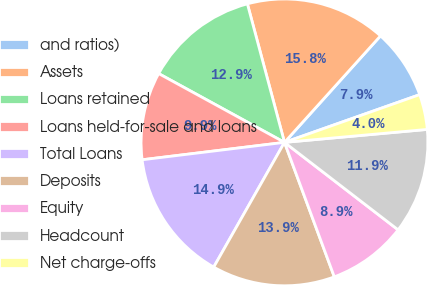Convert chart to OTSL. <chart><loc_0><loc_0><loc_500><loc_500><pie_chart><fcel>and ratios)<fcel>Assets<fcel>Loans retained<fcel>Loans held-for-sale and loans<fcel>Total Loans<fcel>Deposits<fcel>Equity<fcel>Headcount<fcel>Net charge-offs<nl><fcel>7.92%<fcel>15.84%<fcel>12.87%<fcel>9.9%<fcel>14.85%<fcel>13.86%<fcel>8.91%<fcel>11.88%<fcel>3.96%<nl></chart> 